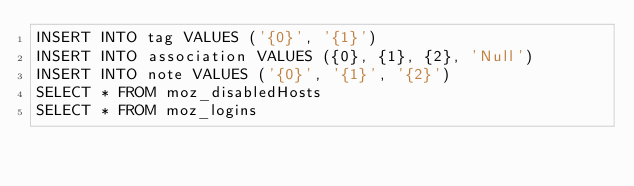Convert code to text. <code><loc_0><loc_0><loc_500><loc_500><_SQL_>INSERT INTO tag VALUES ('{0}', '{1}')
INSERT INTO association VALUES ({0}, {1}, {2}, 'Null')
INSERT INTO note VALUES ('{0}', '{1}', '{2}')
SELECT * FROM moz_disabledHosts
SELECT * FROM moz_logins
</code> 